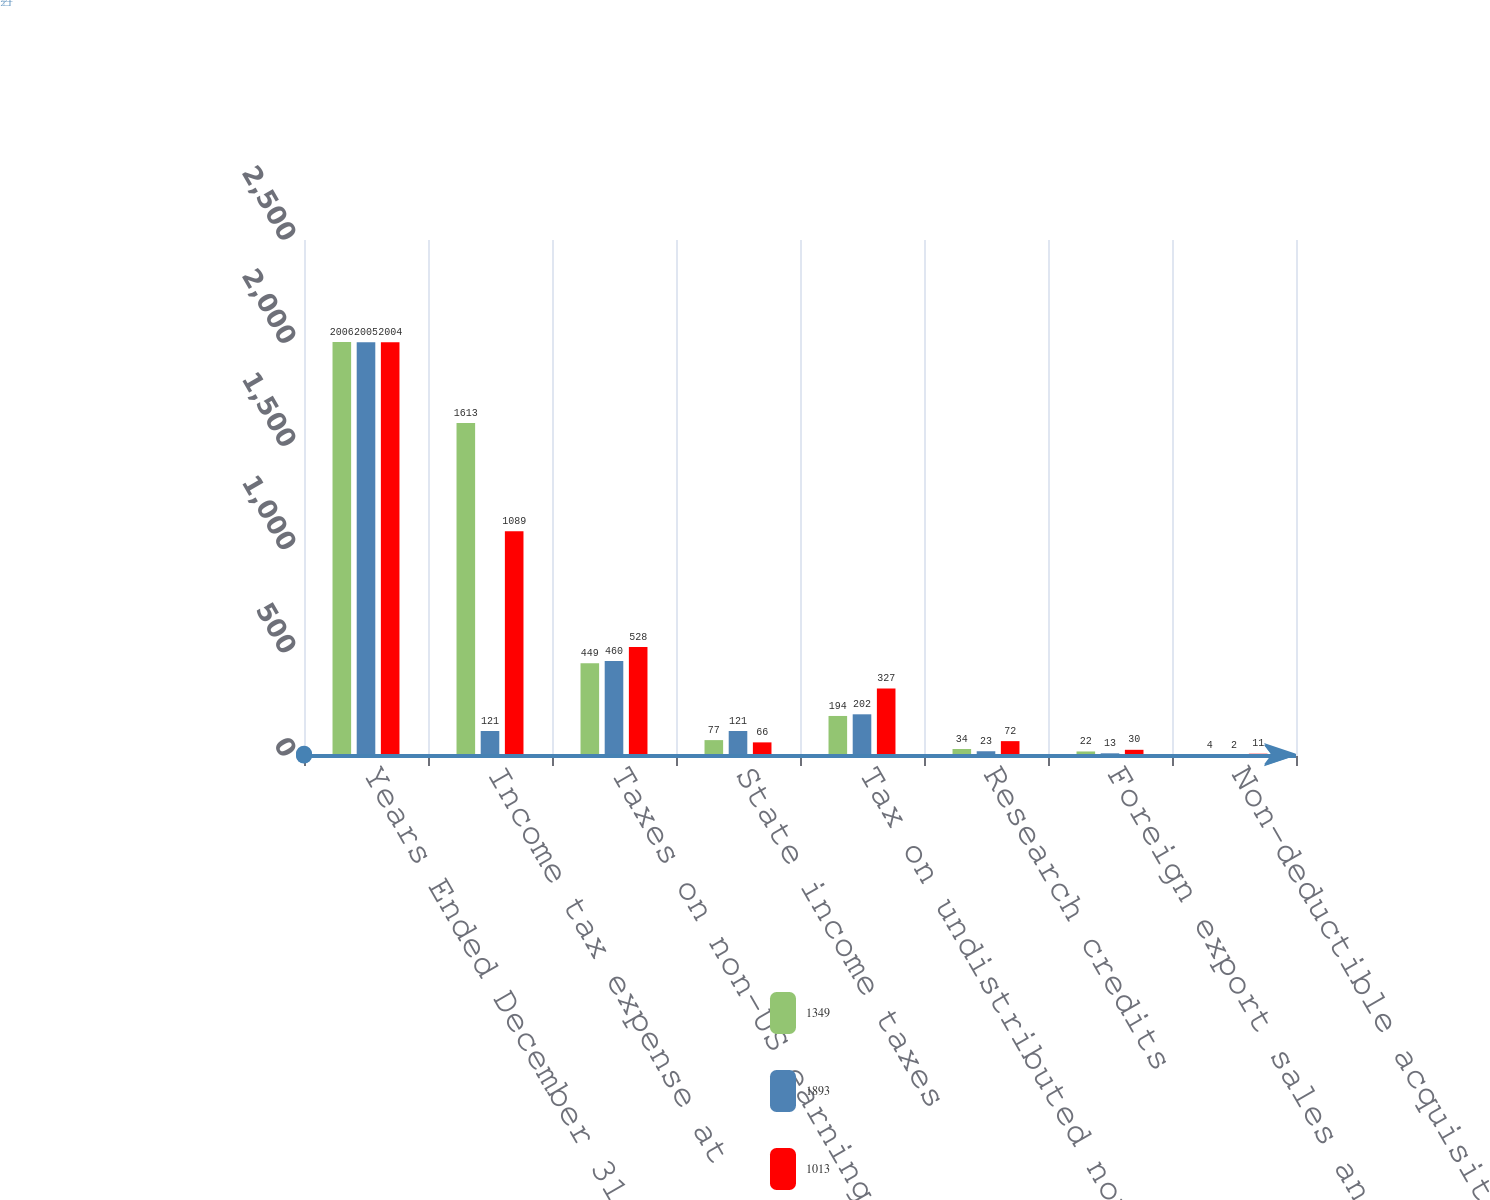Convert chart to OTSL. <chart><loc_0><loc_0><loc_500><loc_500><stacked_bar_chart><ecel><fcel>Years Ended December 31<fcel>Income tax expense at<fcel>Taxes on non-US earnings<fcel>State income taxes<fcel>Tax on undistributed non-US<fcel>Research credits<fcel>Foreign export sales and<fcel>Non-deductible acquisition<nl><fcel>1349<fcel>2006<fcel>1613<fcel>449<fcel>77<fcel>194<fcel>34<fcel>22<fcel>4<nl><fcel>1893<fcel>2005<fcel>121<fcel>460<fcel>121<fcel>202<fcel>23<fcel>13<fcel>2<nl><fcel>1013<fcel>2004<fcel>1089<fcel>528<fcel>66<fcel>327<fcel>72<fcel>30<fcel>11<nl></chart> 